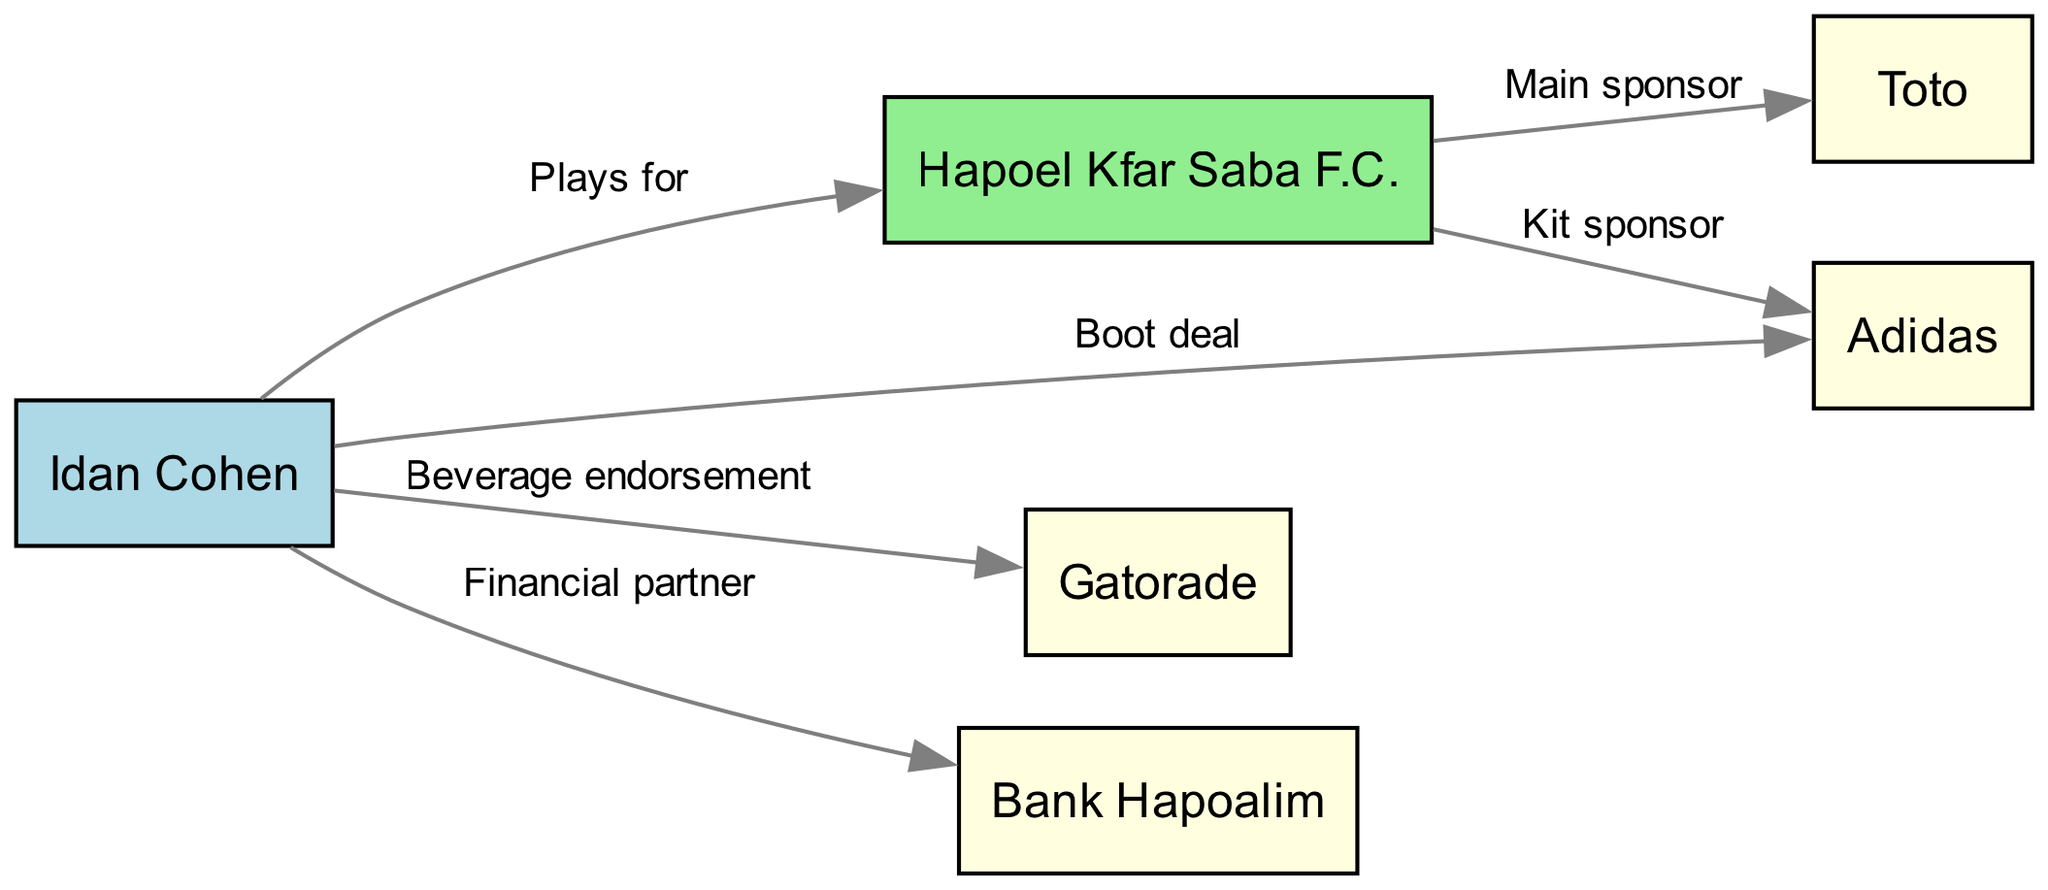What team does Idan Cohen play for? The diagram shows a directed edge from the "Player" node (Idan Cohen) to the "Team" node (Hapoel Kfar Saba F.C.) labeled "Plays for." Therefore, we can identify that he plays for Hapoel Kfar Saba F.C.
Answer: Hapoel Kfar Saba F.C Which brand is the kit sponsor for Hapoel Kfar Saba F.C.? The diagram indicates a directed edge from the "Team" node (Hapoel Kfar Saba F.C.) to the "Brand1" node (Adidas) labeled "Kit sponsor." This clarifies that Adidas is the kit sponsor for the team.
Answer: Adidas How many total brands are mentioned in the diagram? The diagram lists four distinct brand nodes: Adidas, Gatorade, Toto, and Bank Hapoalim. Counting these nodes gives a total of four brands in the sponsorship network.
Answer: 4 What type of endorsement does Idan Cohen have with Gatorade? According to the diagram, there is a directed edge from the "Player" node (Idan Cohen) to the "Brand2" node (Gatorade) labeled "Beverage endorsement." This specifies the type of endorsement he has with Gatorade.
Answer: Beverage endorsement Which brand is the main sponsor of Hapoel Kfar Saba F.C.? The diagram shows a directed edge from the "Team" node (Hapoel Kfar Saba F.C.) to the "Brand3" node (Toto) labeled "Main sponsor." Therefore, Toto is identified as the main sponsor of the team.
Answer: Toto What is the relationship between Idan Cohen and Adidas? The diagram displays a directed edge between the "Player" node (Idan Cohen) and the "Brand1" node (Adidas) labeled "Boot deal." Hence, this specifies that the relationship is a boot deal.
Answer: Boot deal How many nodes represent the connections to brands in this graph? In the diagram, there are four brand nodes: Adidas, Gatorade, Toto, and Bank Hapoalim. These are the nodes that represent all connections to brands within the network.
Answer: 4 Which financial partner is associated with Idan Cohen? The diagram indicates a directed edge from the "Player" node (Idan Cohen) to the "Brand4" node (Bank Hapoalim) labeled "Financial partner," identifying Bank Hapoalim as the financial partner of Idan Cohen.
Answer: Bank Hapoalim 